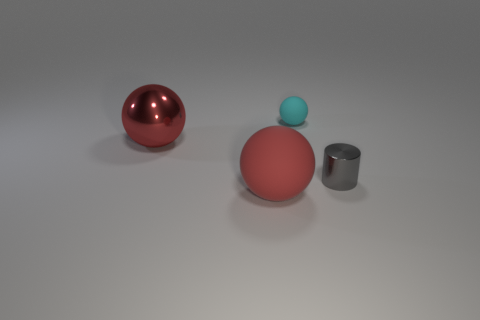Subtract all large rubber spheres. How many spheres are left? 2 Add 2 cyan rubber objects. How many objects exist? 6 Subtract all cyan balls. How many balls are left? 2 Subtract all spheres. How many objects are left? 1 Subtract 1 cylinders. How many cylinders are left? 0 Subtract all cyan cylinders. Subtract all red balls. How many cylinders are left? 1 Subtract all gray cubes. How many cyan spheres are left? 1 Subtract all large brown objects. Subtract all tiny cyan spheres. How many objects are left? 3 Add 1 small spheres. How many small spheres are left? 2 Add 2 red matte things. How many red matte things exist? 3 